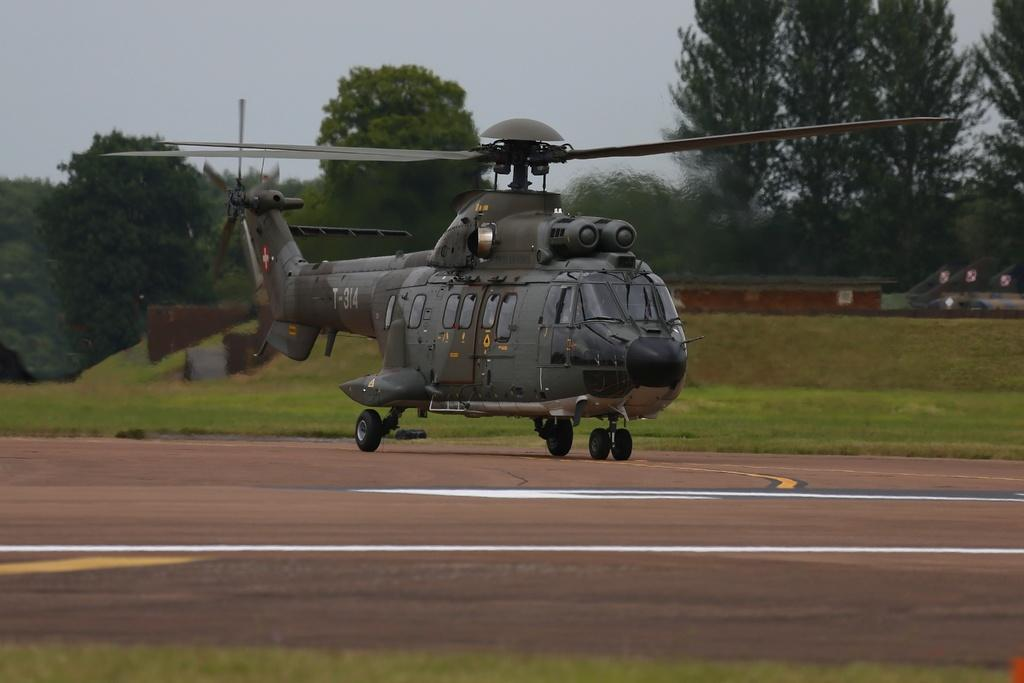What is the main subject of the image? The main subject of the image is a helicopter. What can be seen on the ground in the image? There is green grass on the ground in some areas of the image. What type of vegetation is present in the image? There are trees in the image. What is visible at the top of the image? The sky is visible at the top of the image. What is the condition of the sky in the image? The sky is cloudy in the image. What type of vessel is being used to navigate the water in the image? There is no water or vessel present in the image; it features a helicopter, green grass, trees, and a cloudy sky. What type of curve can be seen on the wing of the helicopter in the image? There is no wing or curve visible on the helicopter in the image; it is a complete helicopter without any visible curves on its wings. 